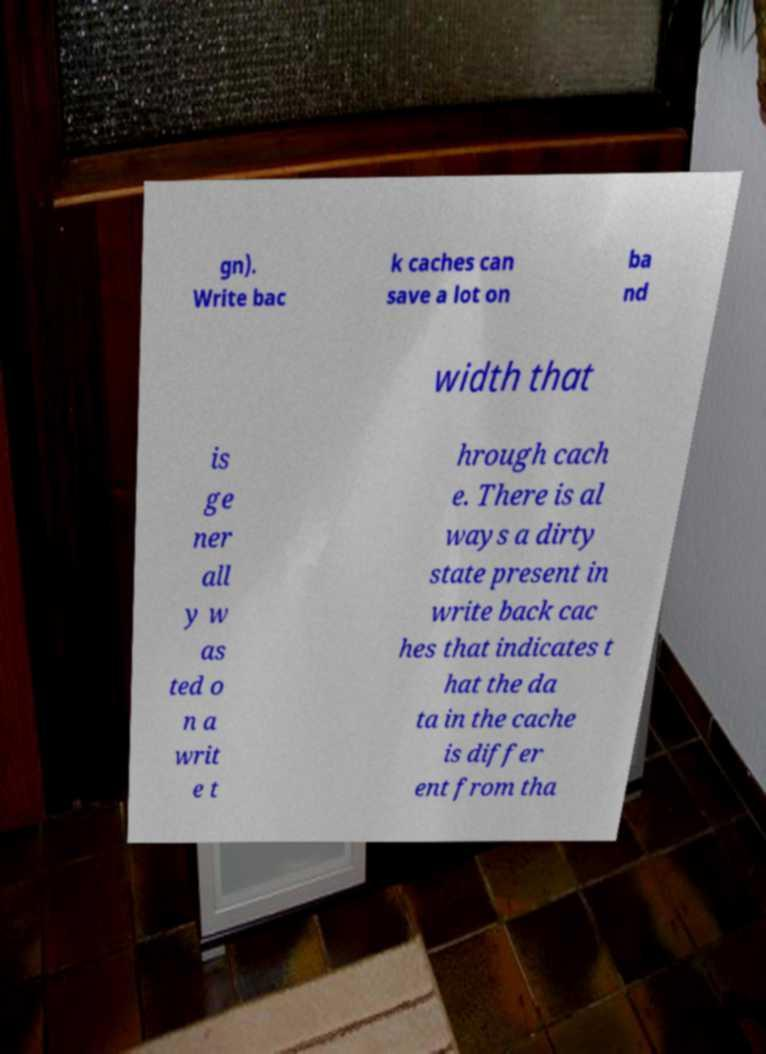I need the written content from this picture converted into text. Can you do that? gn). Write bac k caches can save a lot on ba nd width that is ge ner all y w as ted o n a writ e t hrough cach e. There is al ways a dirty state present in write back cac hes that indicates t hat the da ta in the cache is differ ent from tha 